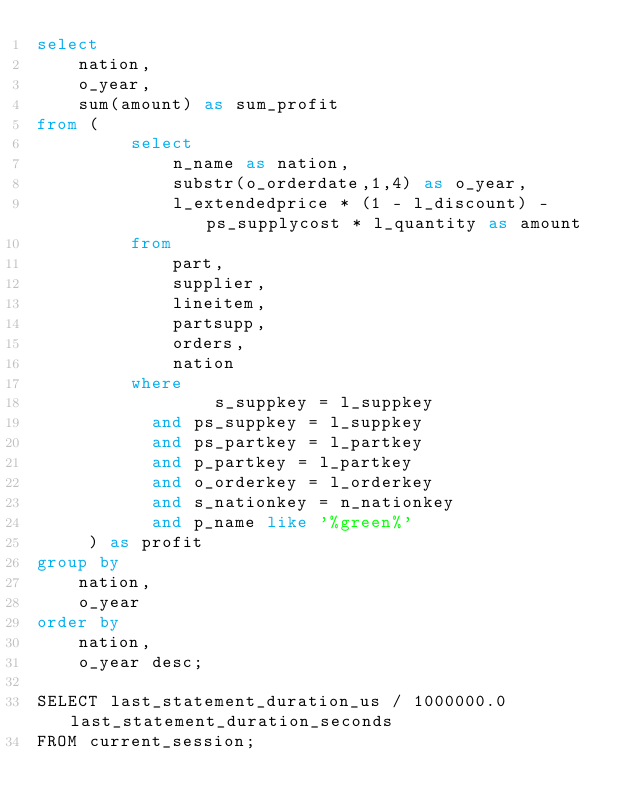Convert code to text. <code><loc_0><loc_0><loc_500><loc_500><_SQL_>select
    nation,
    o_year,
    sum(amount) as sum_profit
from (
         select
             n_name as nation,
             substr(o_orderdate,1,4) as o_year,
             l_extendedprice * (1 - l_discount) - ps_supplycost * l_quantity as amount
         from
             part,
             supplier,
             lineitem,
             partsupp,
             orders,
             nation
         where
                 s_suppkey = l_suppkey
           and ps_suppkey = l_suppkey
           and ps_partkey = l_partkey
           and p_partkey = l_partkey
           and o_orderkey = l_orderkey
           and s_nationkey = n_nationkey
           and p_name like '%green%'
     ) as profit
group by
    nation,
    o_year
order by
    nation,
    o_year desc;

SELECT last_statement_duration_us / 1000000.0 last_statement_duration_seconds
FROM current_session;</code> 